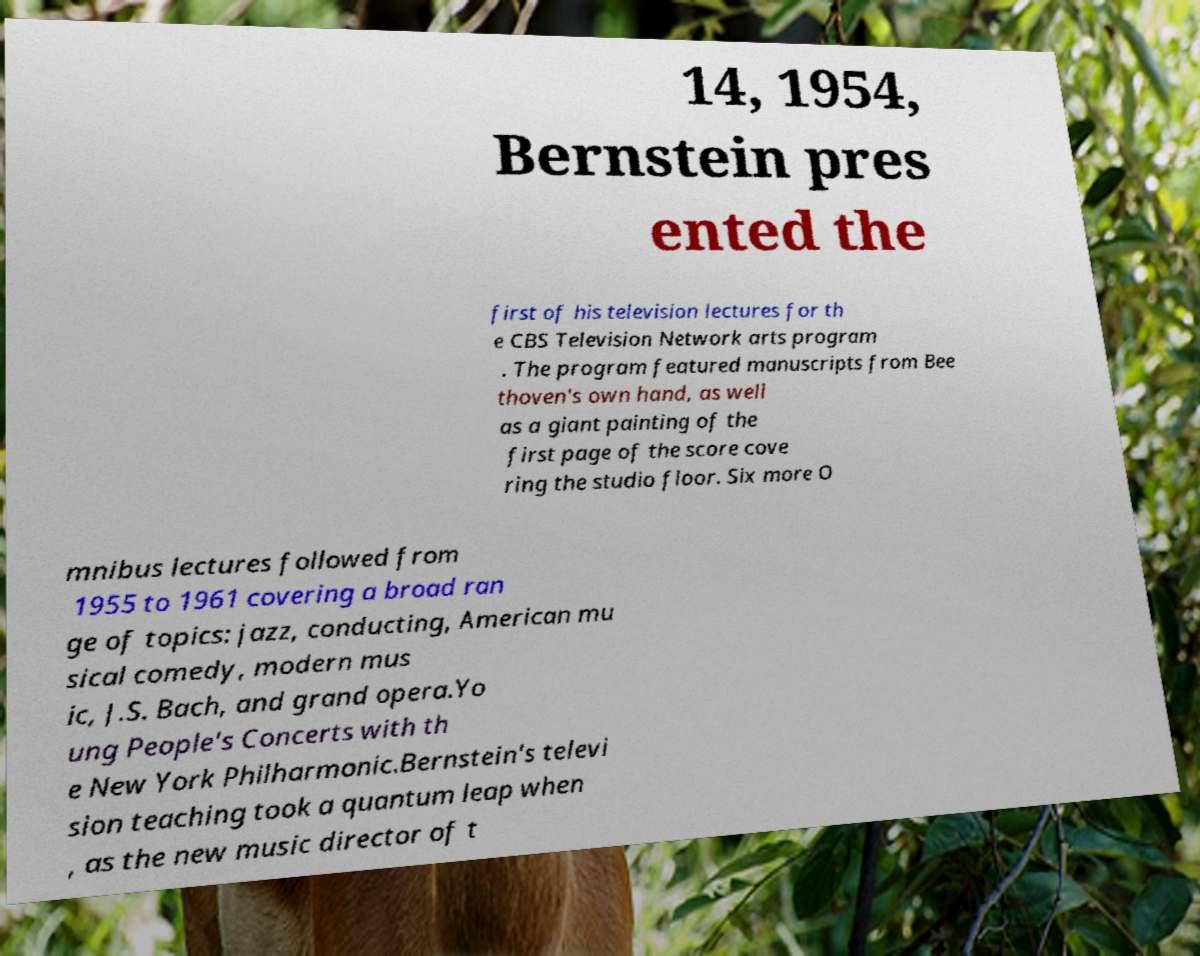Could you assist in decoding the text presented in this image and type it out clearly? 14, 1954, Bernstein pres ented the first of his television lectures for th e CBS Television Network arts program . The program featured manuscripts from Bee thoven's own hand, as well as a giant painting of the first page of the score cove ring the studio floor. Six more O mnibus lectures followed from 1955 to 1961 covering a broad ran ge of topics: jazz, conducting, American mu sical comedy, modern mus ic, J.S. Bach, and grand opera.Yo ung People's Concerts with th e New York Philharmonic.Bernstein's televi sion teaching took a quantum leap when , as the new music director of t 